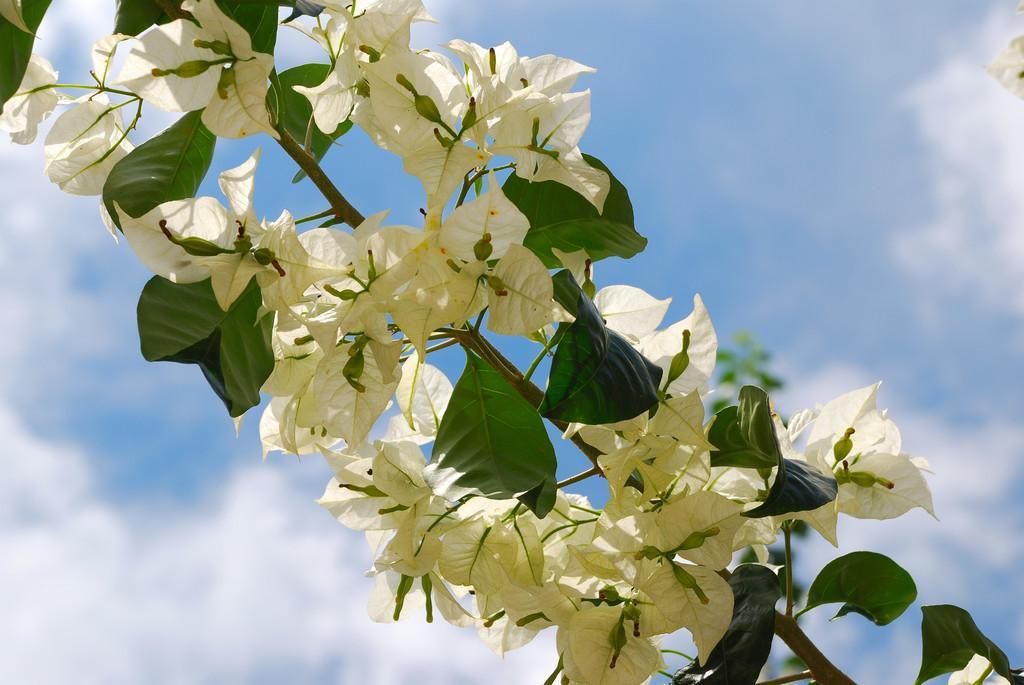Can you describe this image briefly? In this image we can see some flowers on the plant, in the background we can see the sky with clouds. 